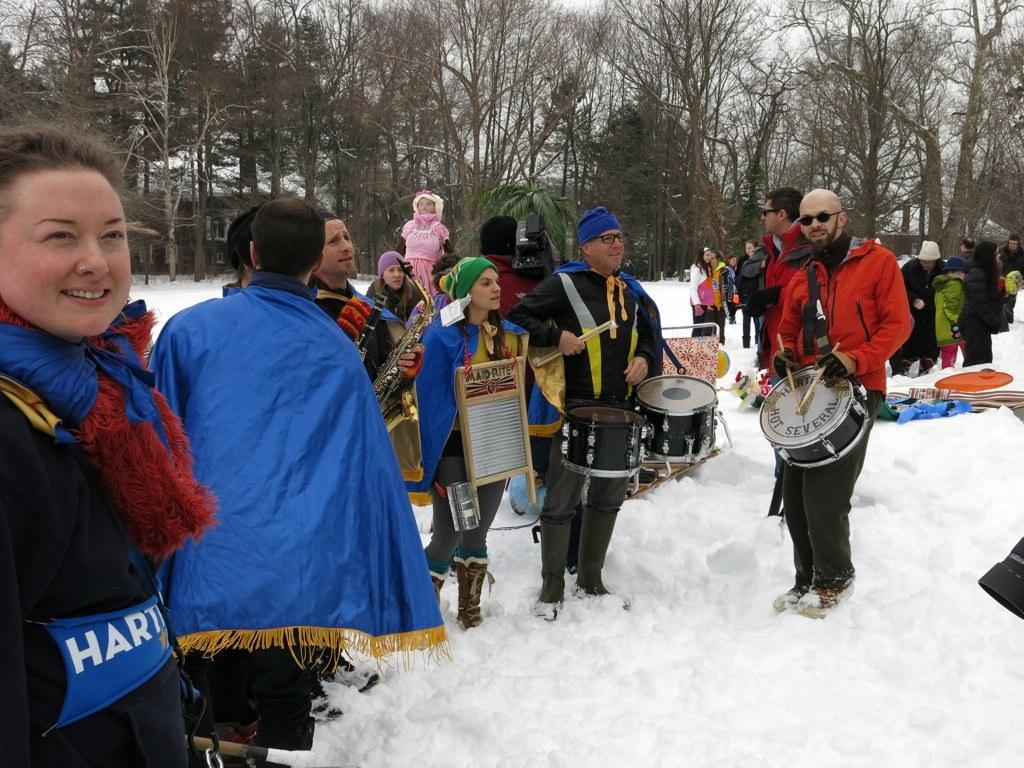<image>
Describe the image concisely. Several people, including a woman holding a washboard that says Maid-Rite, are standing in the snow. 